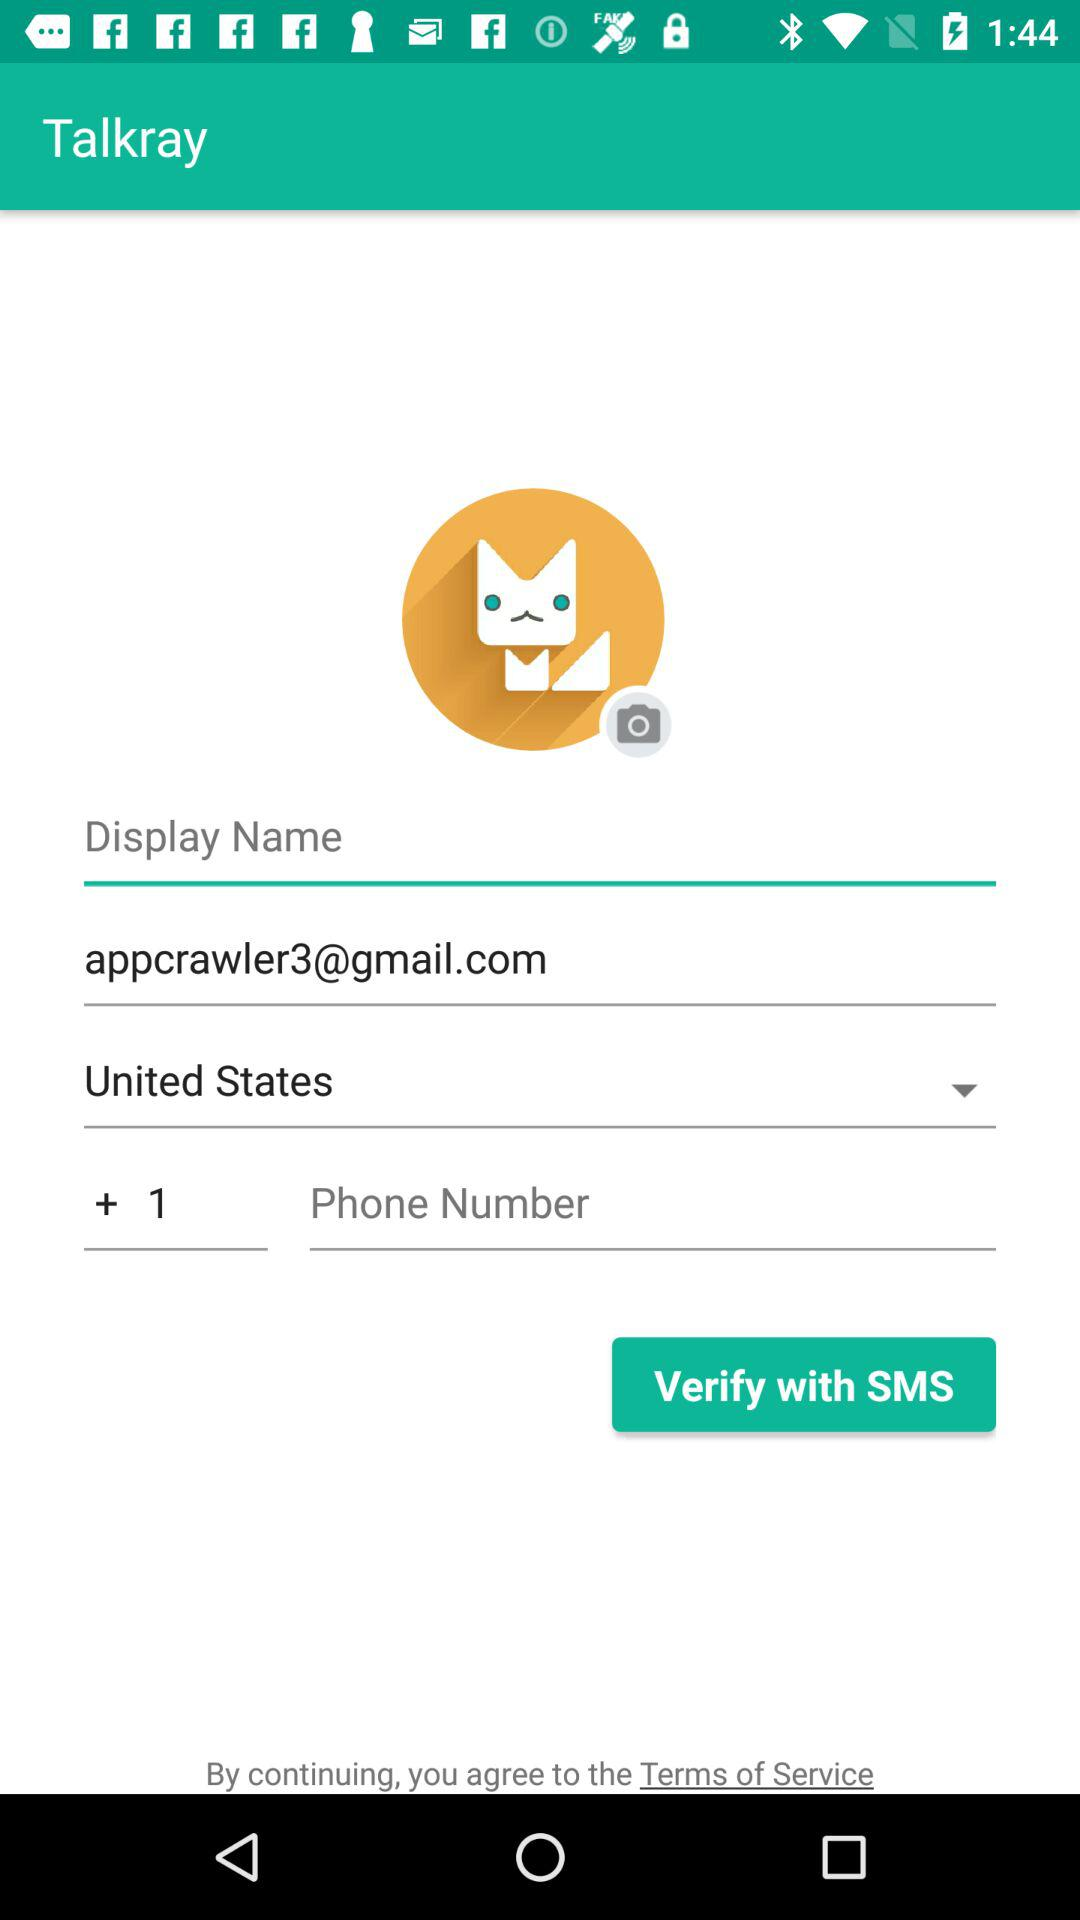Which country is chosen? The chosen country is the United States. 